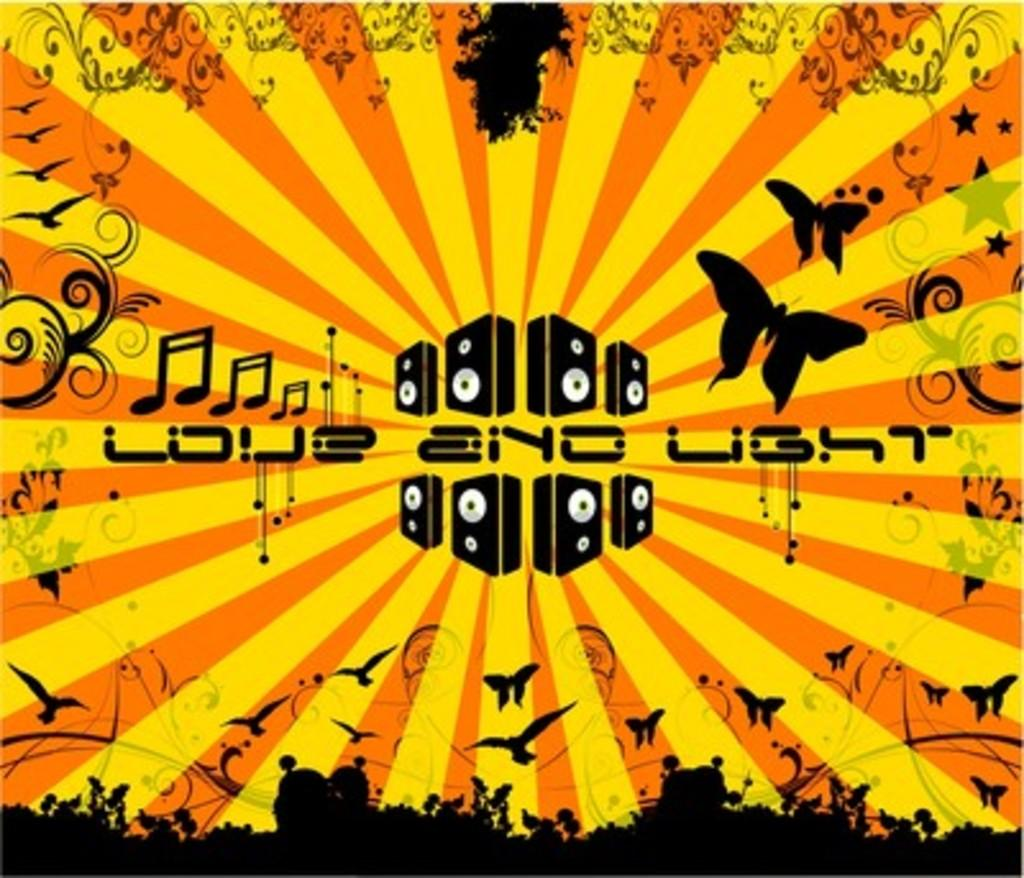Provide a one-sentence caption for the provided image. A poster for Love and Light depicting birds, butterflies and musical notes. 